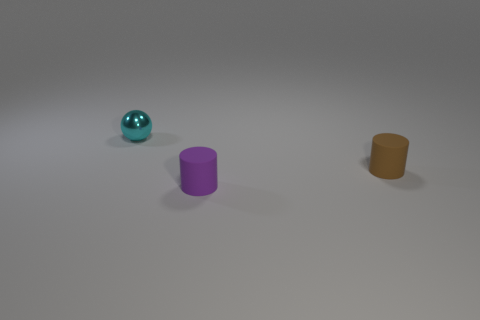Is there any other thing that is the same material as the cyan thing?
Make the answer very short. No. The small shiny sphere behind the rubber cylinder behind the small purple rubber cylinder is what color?
Make the answer very short. Cyan. What is the object that is behind the tiny brown matte thing made of?
Keep it short and to the point. Metal. Is the number of tiny matte objects less than the number of small shiny objects?
Give a very brief answer. No. Do the purple rubber thing and the thing that is behind the tiny brown cylinder have the same shape?
Your answer should be compact. No. What shape is the small object that is behind the purple rubber cylinder and right of the shiny sphere?
Provide a short and direct response. Cylinder. Is the number of spheres that are right of the purple matte cylinder the same as the number of tiny purple objects to the left of the cyan object?
Your response must be concise. Yes. Is the shape of the tiny matte object that is in front of the small brown matte cylinder the same as  the small cyan object?
Provide a short and direct response. No. What number of gray objects are either balls or tiny rubber cylinders?
Your response must be concise. 0. There is a brown object that is the same shape as the purple matte object; what is its material?
Provide a succinct answer. Rubber. 